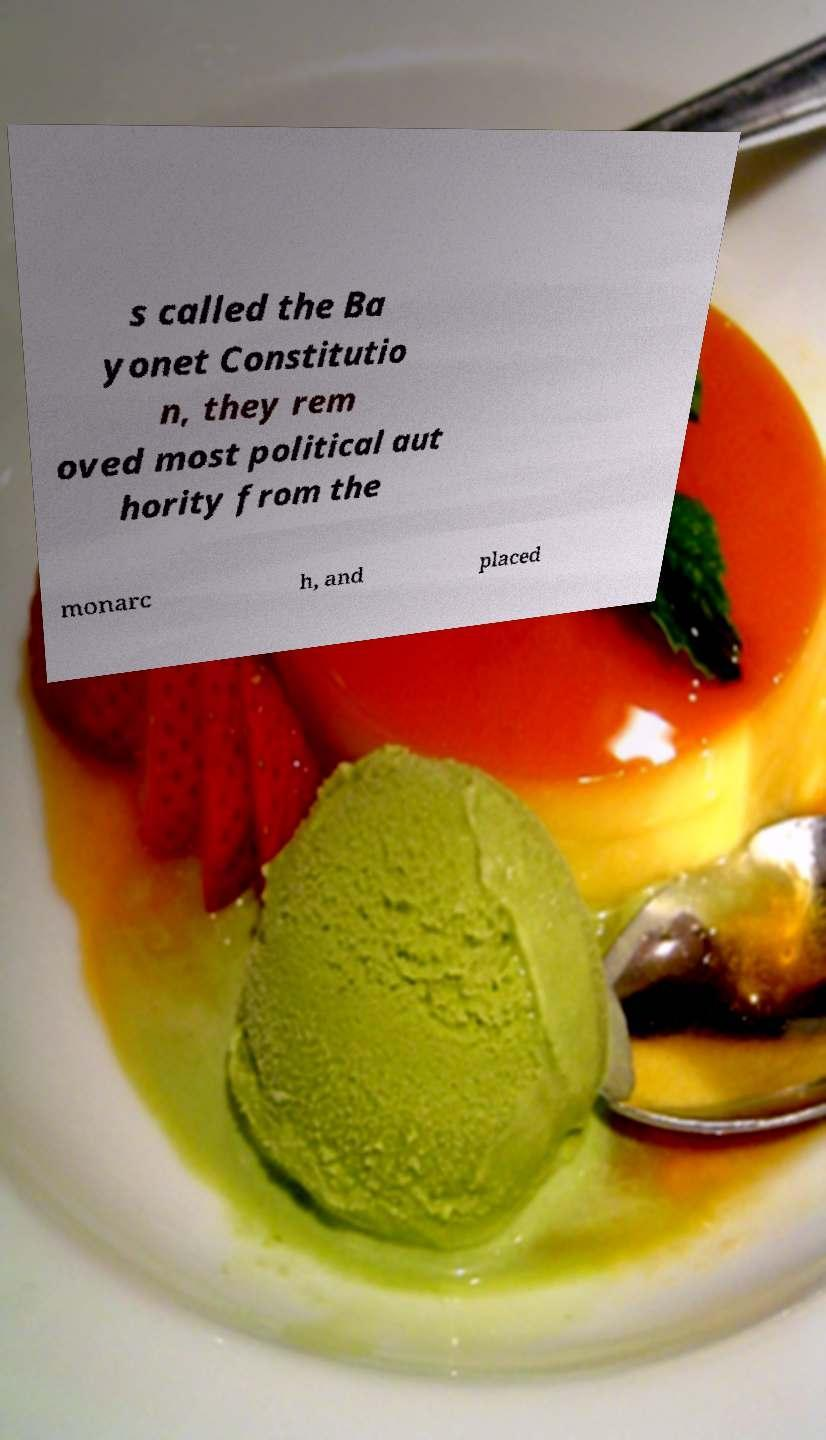I need the written content from this picture converted into text. Can you do that? s called the Ba yonet Constitutio n, they rem oved most political aut hority from the monarc h, and placed 